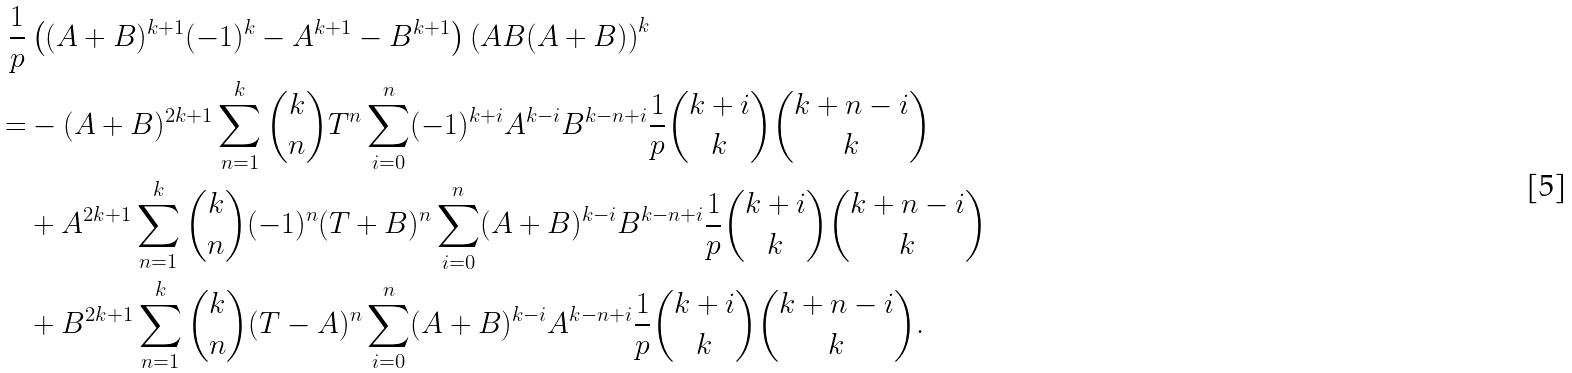<formula> <loc_0><loc_0><loc_500><loc_500>\frac { 1 } { p } & \left ( ( A + B ) ^ { k + 1 } ( - 1 ) ^ { k } - A ^ { k + 1 } - B ^ { k + 1 } \right ) \left ( A B ( A + B ) \right ) ^ { k } \\ = & - ( A + B ) ^ { 2 k + 1 } \sum _ { n = 1 } ^ { k } \binom { k } { n } T ^ { n } \sum _ { i = 0 } ^ { n } ( - 1 ) ^ { k + i } A ^ { k - i } B ^ { k - n + i } \frac { 1 } { p } \binom { k + i } { k } \binom { k + n - i } { k } \\ & + A ^ { 2 k + 1 } \sum _ { n = 1 } ^ { k } \binom { k } { n } ( - 1 ) ^ { n } ( T + B ) ^ { n } \sum _ { i = 0 } ^ { n } ( A + B ) ^ { k - i } B ^ { k - n + i } \frac { 1 } { p } \binom { k + i } { k } \binom { k + n - i } { k } \\ & + B ^ { 2 k + 1 } \sum _ { n = 1 } ^ { k } \binom { k } { n } ( T - A ) ^ { n } \sum _ { i = 0 } ^ { n } ( A + B ) ^ { k - i } A ^ { k - n + i } \frac { 1 } { p } \binom { k + i } { k } \binom { k + n - i } { k } .</formula> 